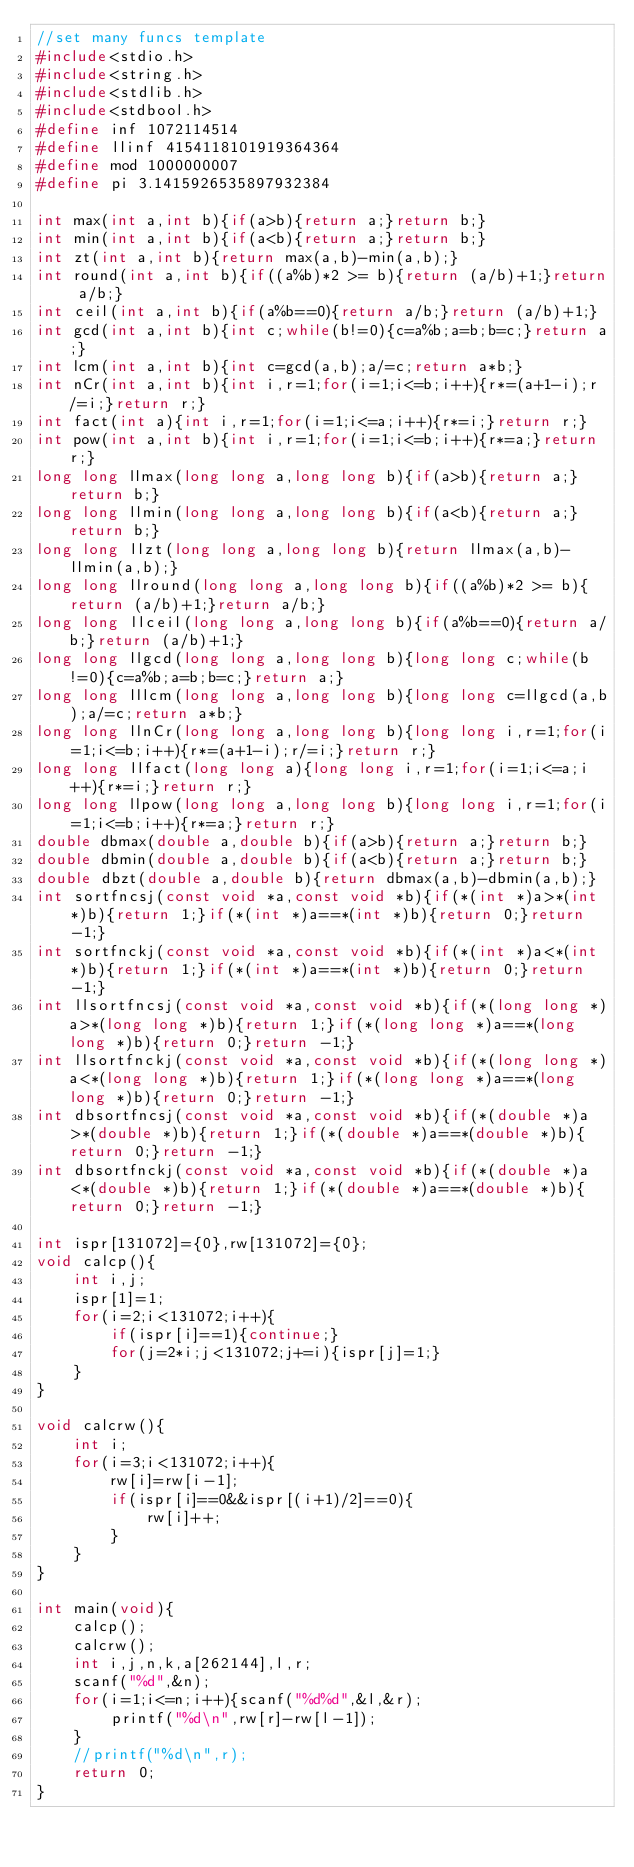Convert code to text. <code><loc_0><loc_0><loc_500><loc_500><_C_>//set many funcs template
#include<stdio.h>
#include<string.h>
#include<stdlib.h>
#include<stdbool.h>
#define inf 1072114514
#define llinf 4154118101919364364
#define mod 1000000007
#define pi 3.1415926535897932384

int max(int a,int b){if(a>b){return a;}return b;}
int min(int a,int b){if(a<b){return a;}return b;}
int zt(int a,int b){return max(a,b)-min(a,b);}
int round(int a,int b){if((a%b)*2 >= b){return (a/b)+1;}return a/b;}
int ceil(int a,int b){if(a%b==0){return a/b;}return (a/b)+1;}
int gcd(int a,int b){int c;while(b!=0){c=a%b;a=b;b=c;}return a;}
int lcm(int a,int b){int c=gcd(a,b);a/=c;return a*b;}
int nCr(int a,int b){int i,r=1;for(i=1;i<=b;i++){r*=(a+1-i);r/=i;}return r;}
int fact(int a){int i,r=1;for(i=1;i<=a;i++){r*=i;}return r;}
int pow(int a,int b){int i,r=1;for(i=1;i<=b;i++){r*=a;}return r;}
long long llmax(long long a,long long b){if(a>b){return a;}return b;}
long long llmin(long long a,long long b){if(a<b){return a;}return b;}
long long llzt(long long a,long long b){return llmax(a,b)-llmin(a,b);}
long long llround(long long a,long long b){if((a%b)*2 >= b){return (a/b)+1;}return a/b;}
long long llceil(long long a,long long b){if(a%b==0){return a/b;}return (a/b)+1;}
long long llgcd(long long a,long long b){long long c;while(b!=0){c=a%b;a=b;b=c;}return a;}
long long lllcm(long long a,long long b){long long c=llgcd(a,b);a/=c;return a*b;}
long long llnCr(long long a,long long b){long long i,r=1;for(i=1;i<=b;i++){r*=(a+1-i);r/=i;}return r;}
long long llfact(long long a){long long i,r=1;for(i=1;i<=a;i++){r*=i;}return r;}
long long llpow(long long a,long long b){long long i,r=1;for(i=1;i<=b;i++){r*=a;}return r;}
double dbmax(double a,double b){if(a>b){return a;}return b;}
double dbmin(double a,double b){if(a<b){return a;}return b;}
double dbzt(double a,double b){return dbmax(a,b)-dbmin(a,b);}
int sortfncsj(const void *a,const void *b){if(*(int *)a>*(int *)b){return 1;}if(*(int *)a==*(int *)b){return 0;}return -1;}
int sortfnckj(const void *a,const void *b){if(*(int *)a<*(int *)b){return 1;}if(*(int *)a==*(int *)b){return 0;}return -1;}
int llsortfncsj(const void *a,const void *b){if(*(long long *)a>*(long long *)b){return 1;}if(*(long long *)a==*(long long *)b){return 0;}return -1;}
int llsortfnckj(const void *a,const void *b){if(*(long long *)a<*(long long *)b){return 1;}if(*(long long *)a==*(long long *)b){return 0;}return -1;}
int dbsortfncsj(const void *a,const void *b){if(*(double *)a>*(double *)b){return 1;}if(*(double *)a==*(double *)b){return 0;}return -1;}
int dbsortfnckj(const void *a,const void *b){if(*(double *)a<*(double *)b){return 1;}if(*(double *)a==*(double *)b){return 0;}return -1;}

int ispr[131072]={0},rw[131072]={0};
void calcp(){
    int i,j;
    ispr[1]=1;
    for(i=2;i<131072;i++){
        if(ispr[i]==1){continue;}
        for(j=2*i;j<131072;j+=i){ispr[j]=1;}
    }
}

void calcrw(){
    int i;
    for(i=3;i<131072;i++){
        rw[i]=rw[i-1];
        if(ispr[i]==0&&ispr[(i+1)/2]==0){
            rw[i]++;
        }
    }
}

int main(void){
    calcp();
    calcrw();
    int i,j,n,k,a[262144],l,r;
    scanf("%d",&n);
    for(i=1;i<=n;i++){scanf("%d%d",&l,&r);
        printf("%d\n",rw[r]-rw[l-1]);
    }
    //printf("%d\n",r);
    return 0;
}</code> 